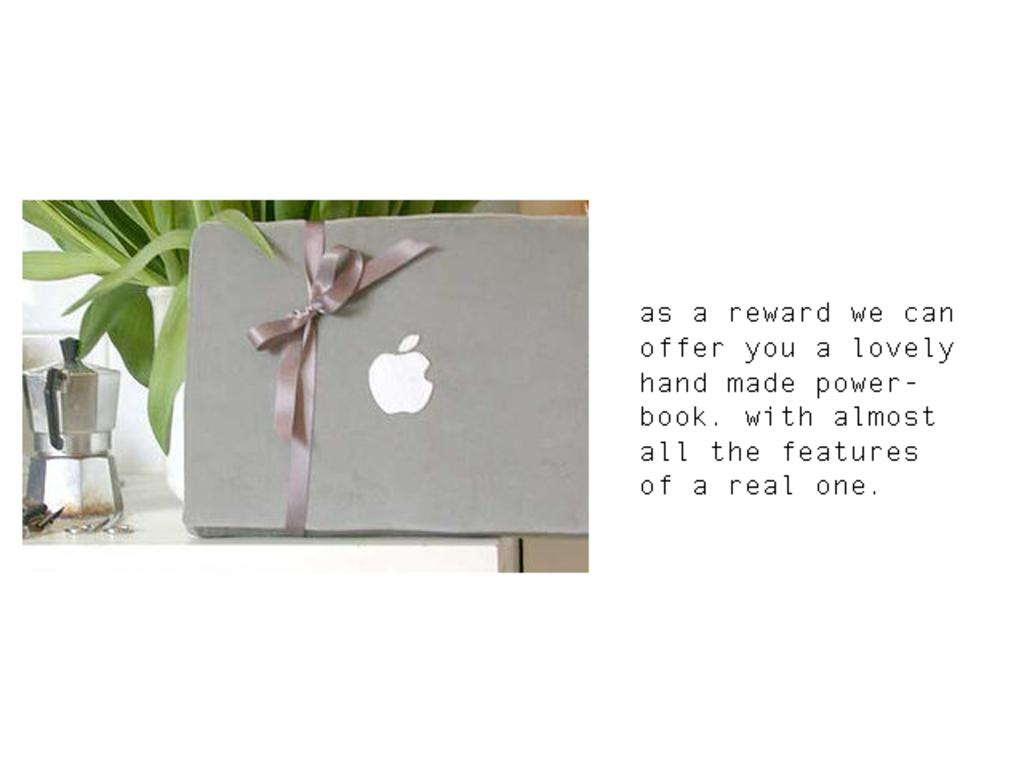<image>
Write a terse but informative summary of the picture. Message with an Apple gift and a mesage that states you will get a reward which is a hand made power book. 